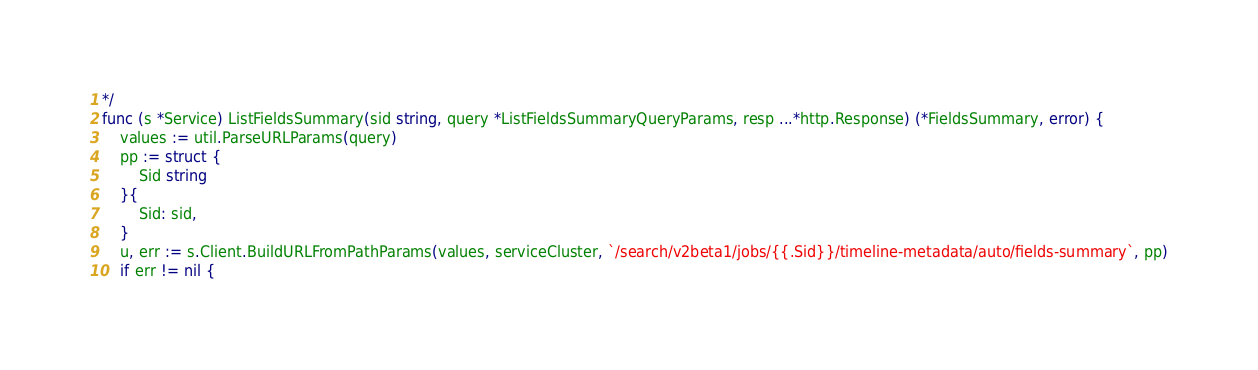Convert code to text. <code><loc_0><loc_0><loc_500><loc_500><_Go_>*/
func (s *Service) ListFieldsSummary(sid string, query *ListFieldsSummaryQueryParams, resp ...*http.Response) (*FieldsSummary, error) {
	values := util.ParseURLParams(query)
	pp := struct {
		Sid string
	}{
		Sid: sid,
	}
	u, err := s.Client.BuildURLFromPathParams(values, serviceCluster, `/search/v2beta1/jobs/{{.Sid}}/timeline-metadata/auto/fields-summary`, pp)
	if err != nil {</code> 